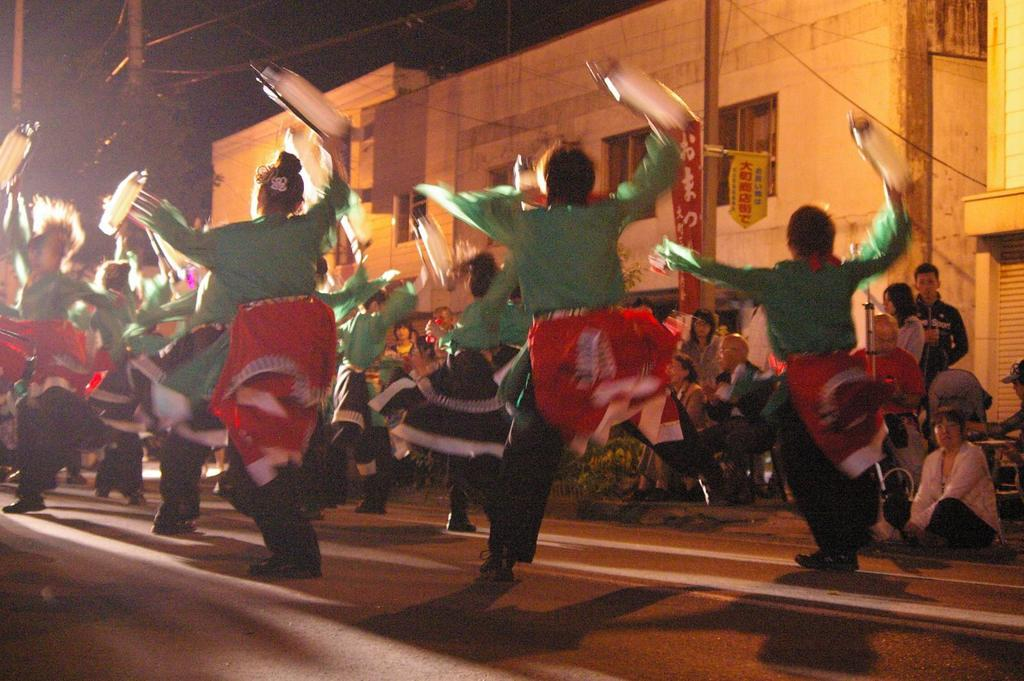What are the people in the image doing? The people in the image are dancing. What are the people wearing while dancing? The people are wearing costumes. What can be seen in the background of the image? There are buildings, poles, wires, and the sky visible in the background of the image. How many people are in the image? There is a crowd in the image, which suggests that there are multiple people present. What is the wrist rate of the person in the image? There is no mention of a wrist or any measurement of a person's rate in the image. --- Facts: 1. There is a car in the image. 2. The car is red. 3. The car has four wheels. 4. There is a person in the car. 5. The person is wearing a seatbelt. 6. The car is parked on the side of the road. 7. There is a tree next to the car. Absurd Topics: bird, ocean, mountain Conversation: What type of vehicle is in the image? There is a car in the image. What color is the car? The car is red. How many wheels does the car have? The car has four wheels. Is there anyone inside the car? Yes, there is a person in the car. What safety measure is the person in the car taking? The person is wearing a seatbelt. Where is the car located in the image? The car is parked on the side of the road. What can be seen next to the car? There is a tree next to the car. Reasoning: Let's think step by step in order to produce the conversation. We start by identifying the main subject in the image, which is the car. Then, we describe the car's color and the number of wheels it has. Next, we mention the presence of a person inside the car and their use of a seatbelt. We then describe the car's location, which is parked on the side of the road. Finally, we acknowledge the presence of a tree next to the car. Absurd Question/Answer: Can you see any mountains in the background of the image? There is no mention of mountains in the image; it only shows a car parked on the side of the road with a tree next to it. 